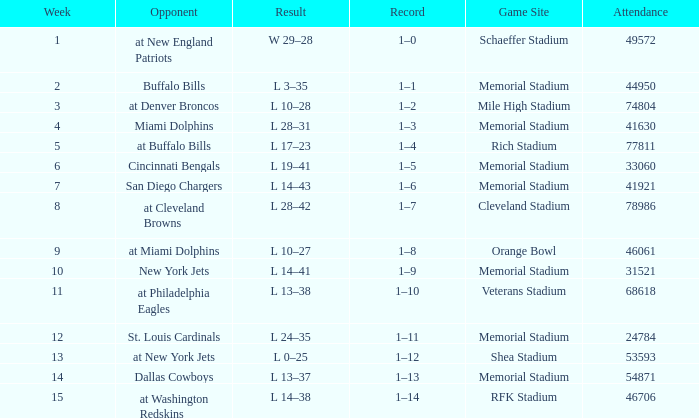When it is October 18, 1981 where is the game site? Memorial Stadium. 